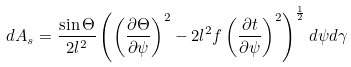<formula> <loc_0><loc_0><loc_500><loc_500>d A _ { s } = \frac { \sin \Theta } { 2 l ^ { 2 } } \left ( \left ( \frac { \partial \Theta } { \partial \psi } \right ) ^ { 2 } - 2 l ^ { 2 } f \left ( \frac { \partial t } { \partial \psi } \right ) ^ { 2 } \right ) ^ { \frac { 1 } { 2 } } d \psi d \gamma</formula> 